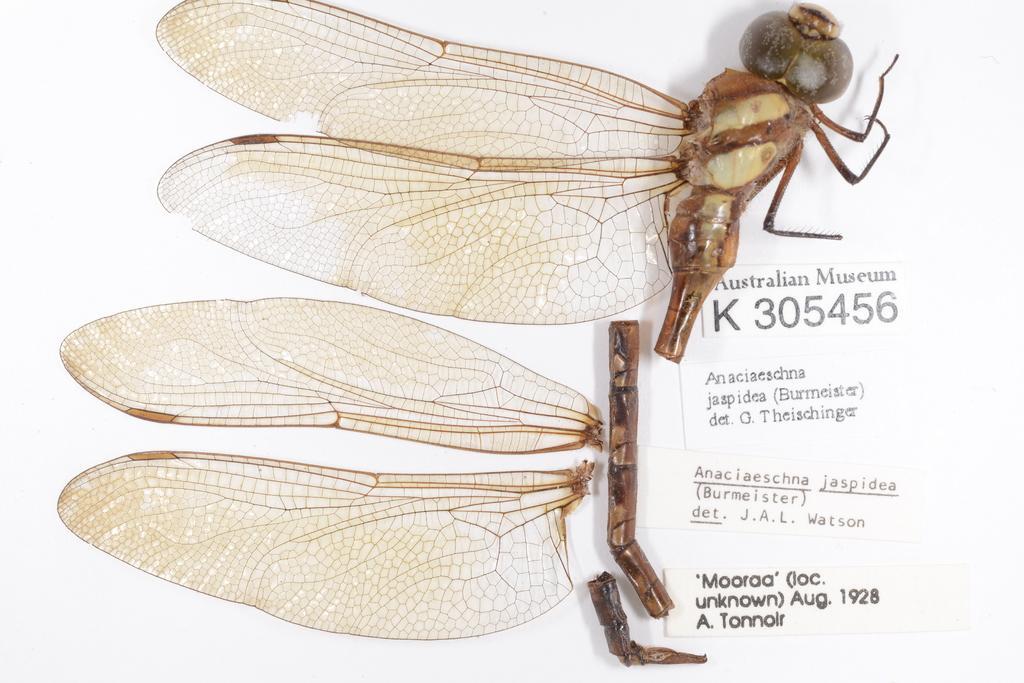How would you summarize this image in a sentence or two? In this picture, we see some pieces of the dragonfly. On the right side, we see the white stickers with some text written on it. In the background, it is white in color. 